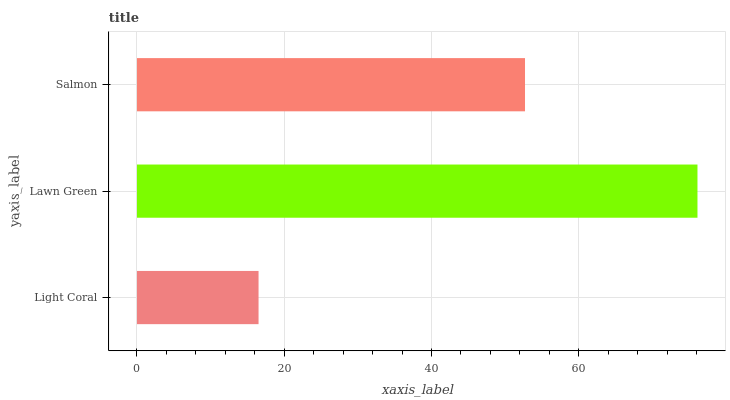Is Light Coral the minimum?
Answer yes or no. Yes. Is Lawn Green the maximum?
Answer yes or no. Yes. Is Salmon the minimum?
Answer yes or no. No. Is Salmon the maximum?
Answer yes or no. No. Is Lawn Green greater than Salmon?
Answer yes or no. Yes. Is Salmon less than Lawn Green?
Answer yes or no. Yes. Is Salmon greater than Lawn Green?
Answer yes or no. No. Is Lawn Green less than Salmon?
Answer yes or no. No. Is Salmon the high median?
Answer yes or no. Yes. Is Salmon the low median?
Answer yes or no. Yes. Is Lawn Green the high median?
Answer yes or no. No. Is Light Coral the low median?
Answer yes or no. No. 